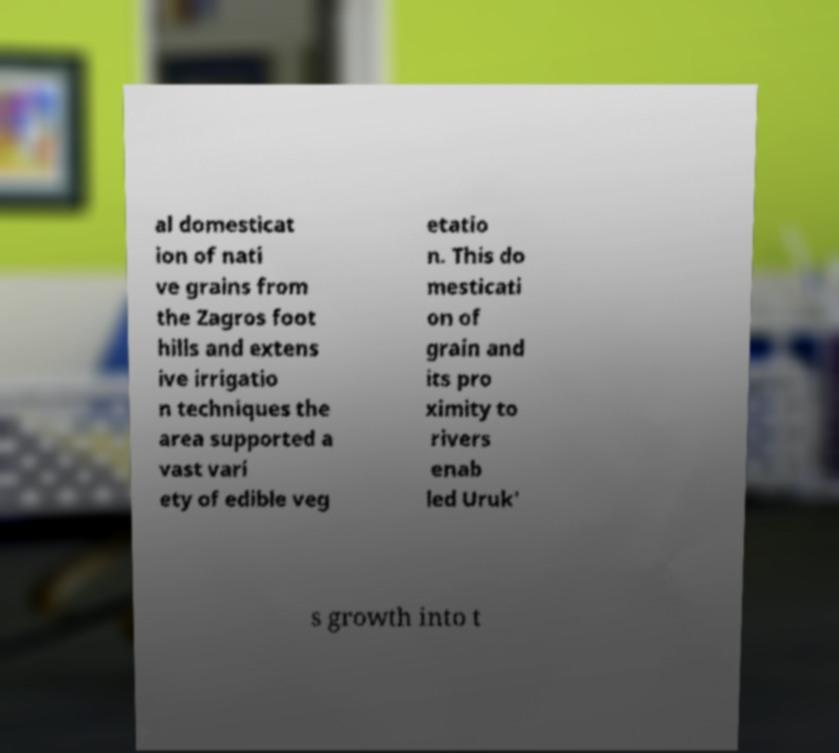Could you extract and type out the text from this image? al domesticat ion of nati ve grains from the Zagros foot hills and extens ive irrigatio n techniques the area supported a vast vari ety of edible veg etatio n. This do mesticati on of grain and its pro ximity to rivers enab led Uruk' s growth into t 